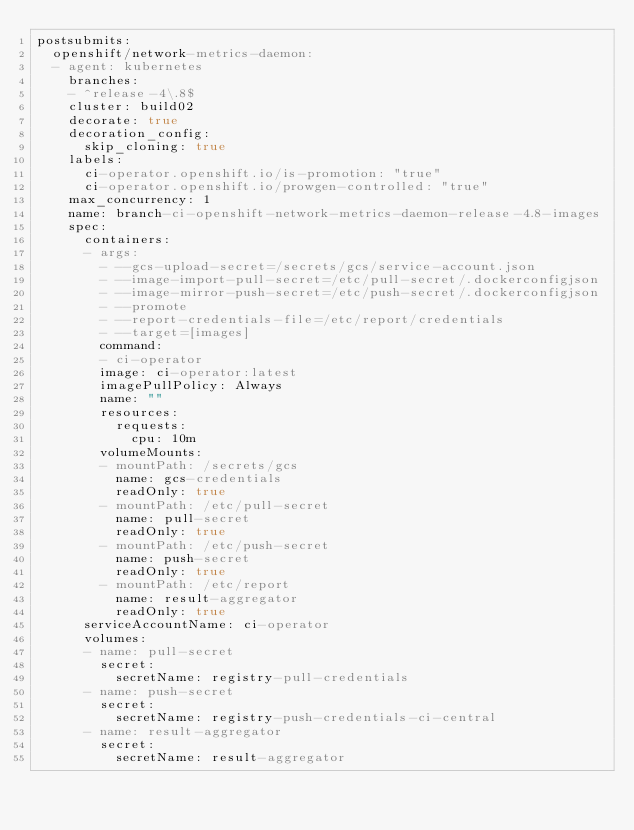Convert code to text. <code><loc_0><loc_0><loc_500><loc_500><_YAML_>postsubmits:
  openshift/network-metrics-daemon:
  - agent: kubernetes
    branches:
    - ^release-4\.8$
    cluster: build02
    decorate: true
    decoration_config:
      skip_cloning: true
    labels:
      ci-operator.openshift.io/is-promotion: "true"
      ci-operator.openshift.io/prowgen-controlled: "true"
    max_concurrency: 1
    name: branch-ci-openshift-network-metrics-daemon-release-4.8-images
    spec:
      containers:
      - args:
        - --gcs-upload-secret=/secrets/gcs/service-account.json
        - --image-import-pull-secret=/etc/pull-secret/.dockerconfigjson
        - --image-mirror-push-secret=/etc/push-secret/.dockerconfigjson
        - --promote
        - --report-credentials-file=/etc/report/credentials
        - --target=[images]
        command:
        - ci-operator
        image: ci-operator:latest
        imagePullPolicy: Always
        name: ""
        resources:
          requests:
            cpu: 10m
        volumeMounts:
        - mountPath: /secrets/gcs
          name: gcs-credentials
          readOnly: true
        - mountPath: /etc/pull-secret
          name: pull-secret
          readOnly: true
        - mountPath: /etc/push-secret
          name: push-secret
          readOnly: true
        - mountPath: /etc/report
          name: result-aggregator
          readOnly: true
      serviceAccountName: ci-operator
      volumes:
      - name: pull-secret
        secret:
          secretName: registry-pull-credentials
      - name: push-secret
        secret:
          secretName: registry-push-credentials-ci-central
      - name: result-aggregator
        secret:
          secretName: result-aggregator
</code> 